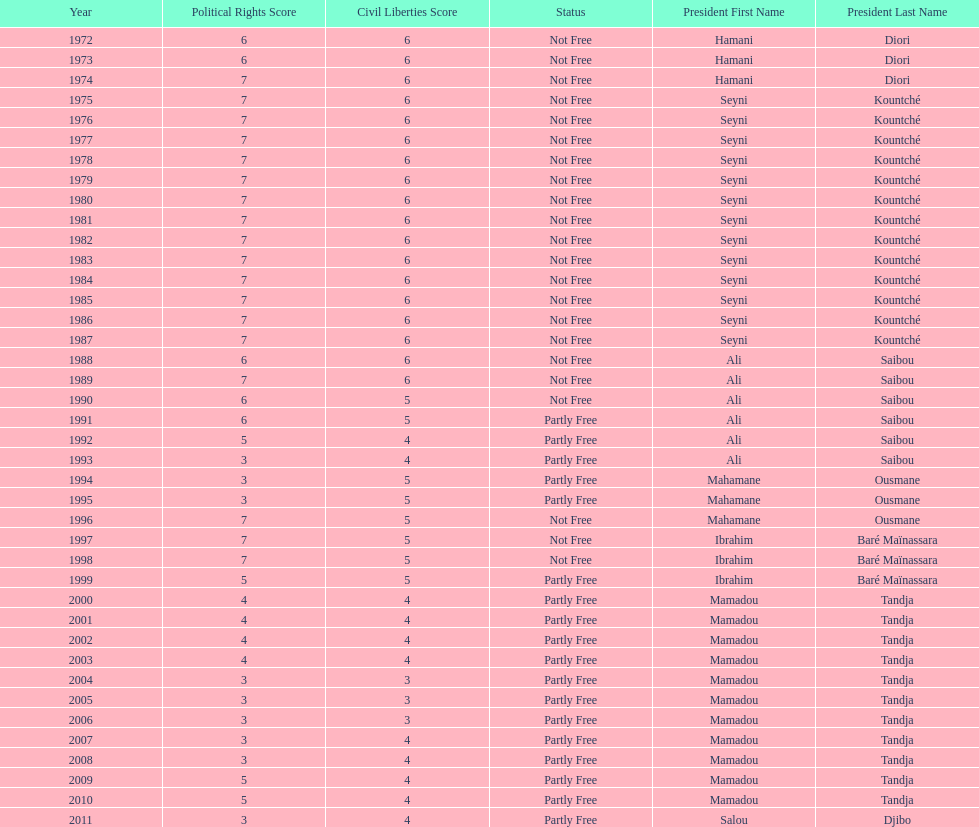Could you parse the entire table? {'header': ['Year', 'Political Rights Score', 'Civil Liberties Score', 'Status', 'President First Name', 'President Last Name'], 'rows': [['1972', '6', '6', 'Not Free', 'Hamani', 'Diori'], ['1973', '6', '6', 'Not Free', 'Hamani', 'Diori'], ['1974', '7', '6', 'Not Free', 'Hamani', 'Diori'], ['1975', '7', '6', 'Not Free', 'Seyni', 'Kountché'], ['1976', '7', '6', 'Not Free', 'Seyni', 'Kountché'], ['1977', '7', '6', 'Not Free', 'Seyni', 'Kountché'], ['1978', '7', '6', 'Not Free', 'Seyni', 'Kountché'], ['1979', '7', '6', 'Not Free', 'Seyni', 'Kountché'], ['1980', '7', '6', 'Not Free', 'Seyni', 'Kountché'], ['1981', '7', '6', 'Not Free', 'Seyni', 'Kountché'], ['1982', '7', '6', 'Not Free', 'Seyni', 'Kountché'], ['1983', '7', '6', 'Not Free', 'Seyni', 'Kountché'], ['1984', '7', '6', 'Not Free', 'Seyni', 'Kountché'], ['1985', '7', '6', 'Not Free', 'Seyni', 'Kountché'], ['1986', '7', '6', 'Not Free', 'Seyni', 'Kountché'], ['1987', '7', '6', 'Not Free', 'Seyni', 'Kountché'], ['1988', '6', '6', 'Not Free', 'Ali', 'Saibou'], ['1989', '7', '6', 'Not Free', 'Ali', 'Saibou'], ['1990', '6', '5', 'Not Free', 'Ali', 'Saibou'], ['1991', '6', '5', 'Partly Free', 'Ali', 'Saibou'], ['1992', '5', '4', 'Partly Free', 'Ali', 'Saibou'], ['1993', '3', '4', 'Partly Free', 'Ali', 'Saibou'], ['1994', '3', '5', 'Partly Free', 'Mahamane', 'Ousmane'], ['1995', '3', '5', 'Partly Free', 'Mahamane', 'Ousmane'], ['1996', '7', '5', 'Not Free', 'Mahamane', 'Ousmane'], ['1997', '7', '5', 'Not Free', 'Ibrahim', 'Baré Maïnassara'], ['1998', '7', '5', 'Not Free', 'Ibrahim', 'Baré Maïnassara'], ['1999', '5', '5', 'Partly Free', 'Ibrahim', 'Baré Maïnassara'], ['2000', '4', '4', 'Partly Free', 'Mamadou', 'Tandja'], ['2001', '4', '4', 'Partly Free', 'Mamadou', 'Tandja'], ['2002', '4', '4', 'Partly Free', 'Mamadou', 'Tandja'], ['2003', '4', '4', 'Partly Free', 'Mamadou', 'Tandja'], ['2004', '3', '3', 'Partly Free', 'Mamadou', 'Tandja'], ['2005', '3', '3', 'Partly Free', 'Mamadou', 'Tandja'], ['2006', '3', '3', 'Partly Free', 'Mamadou', 'Tandja'], ['2007', '3', '4', 'Partly Free', 'Mamadou', 'Tandja'], ['2008', '3', '4', 'Partly Free', 'Mamadou', 'Tandja'], ['2009', '5', '4', 'Partly Free', 'Mamadou', 'Tandja'], ['2010', '5', '4', 'Partly Free', 'Mamadou', 'Tandja'], ['2011', '3', '4', 'Partly Free', 'Salou', 'Djibo']]} How many years was ali saibou president? 6. 